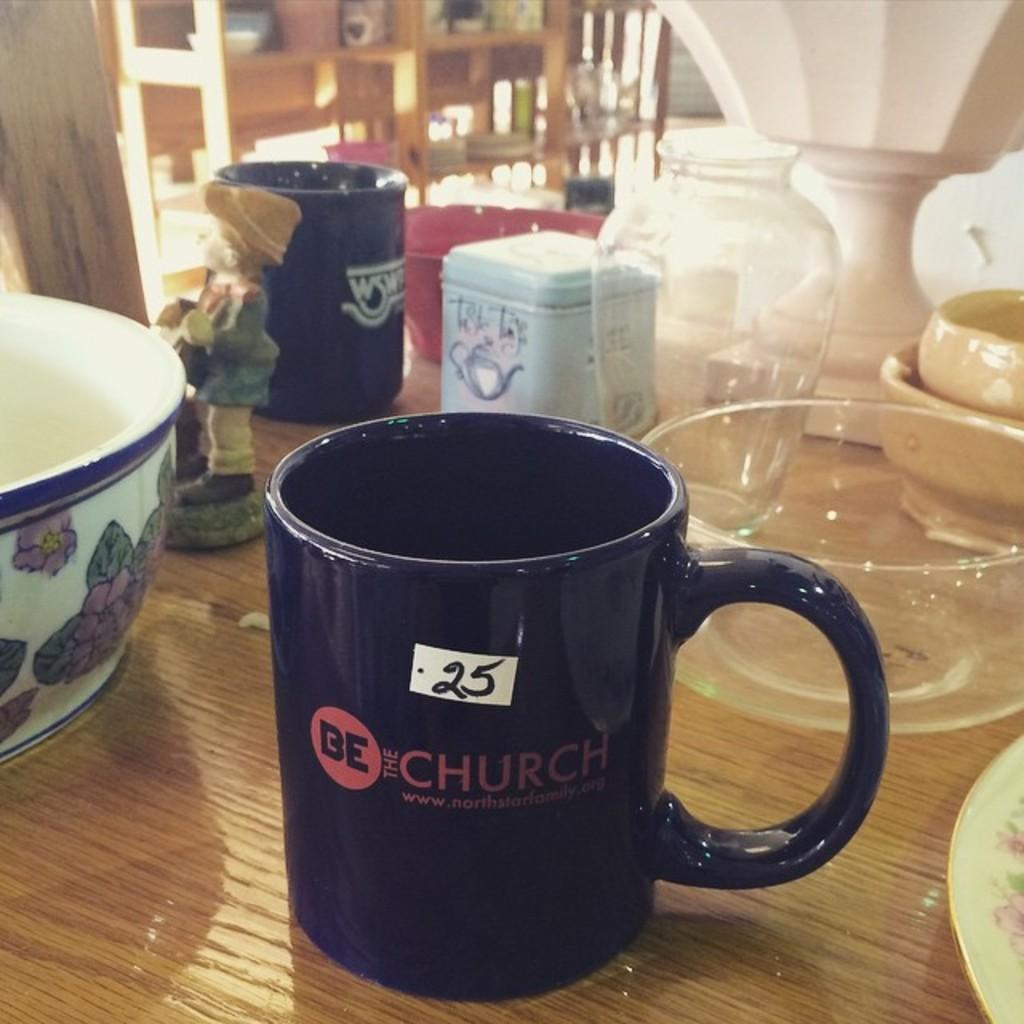Provide a one-sentence caption for the provided image. A Church themed mug sits between two bowls. 